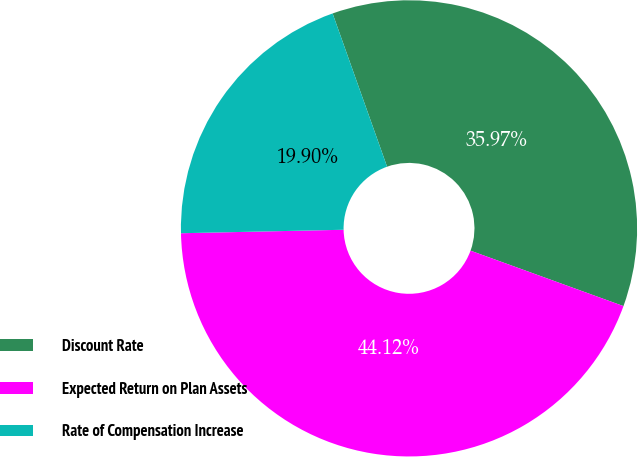<chart> <loc_0><loc_0><loc_500><loc_500><pie_chart><fcel>Discount Rate<fcel>Expected Return on Plan Assets<fcel>Rate of Compensation Increase<nl><fcel>35.97%<fcel>44.12%<fcel>19.9%<nl></chart> 